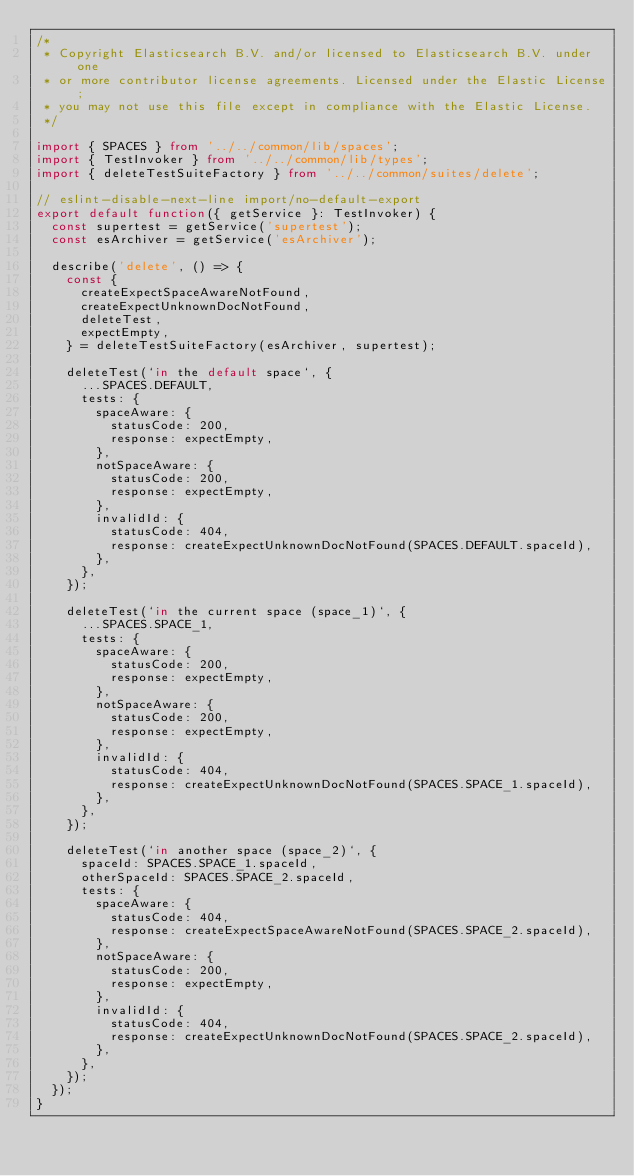Convert code to text. <code><loc_0><loc_0><loc_500><loc_500><_TypeScript_>/*
 * Copyright Elasticsearch B.V. and/or licensed to Elasticsearch B.V. under one
 * or more contributor license agreements. Licensed under the Elastic License;
 * you may not use this file except in compliance with the Elastic License.
 */

import { SPACES } from '../../common/lib/spaces';
import { TestInvoker } from '../../common/lib/types';
import { deleteTestSuiteFactory } from '../../common/suites/delete';

// eslint-disable-next-line import/no-default-export
export default function({ getService }: TestInvoker) {
  const supertest = getService('supertest');
  const esArchiver = getService('esArchiver');

  describe('delete', () => {
    const {
      createExpectSpaceAwareNotFound,
      createExpectUnknownDocNotFound,
      deleteTest,
      expectEmpty,
    } = deleteTestSuiteFactory(esArchiver, supertest);

    deleteTest(`in the default space`, {
      ...SPACES.DEFAULT,
      tests: {
        spaceAware: {
          statusCode: 200,
          response: expectEmpty,
        },
        notSpaceAware: {
          statusCode: 200,
          response: expectEmpty,
        },
        invalidId: {
          statusCode: 404,
          response: createExpectUnknownDocNotFound(SPACES.DEFAULT.spaceId),
        },
      },
    });

    deleteTest(`in the current space (space_1)`, {
      ...SPACES.SPACE_1,
      tests: {
        spaceAware: {
          statusCode: 200,
          response: expectEmpty,
        },
        notSpaceAware: {
          statusCode: 200,
          response: expectEmpty,
        },
        invalidId: {
          statusCode: 404,
          response: createExpectUnknownDocNotFound(SPACES.SPACE_1.spaceId),
        },
      },
    });

    deleteTest(`in another space (space_2)`, {
      spaceId: SPACES.SPACE_1.spaceId,
      otherSpaceId: SPACES.SPACE_2.spaceId,
      tests: {
        spaceAware: {
          statusCode: 404,
          response: createExpectSpaceAwareNotFound(SPACES.SPACE_2.spaceId),
        },
        notSpaceAware: {
          statusCode: 200,
          response: expectEmpty,
        },
        invalidId: {
          statusCode: 404,
          response: createExpectUnknownDocNotFound(SPACES.SPACE_2.spaceId),
        },
      },
    });
  });
}
</code> 